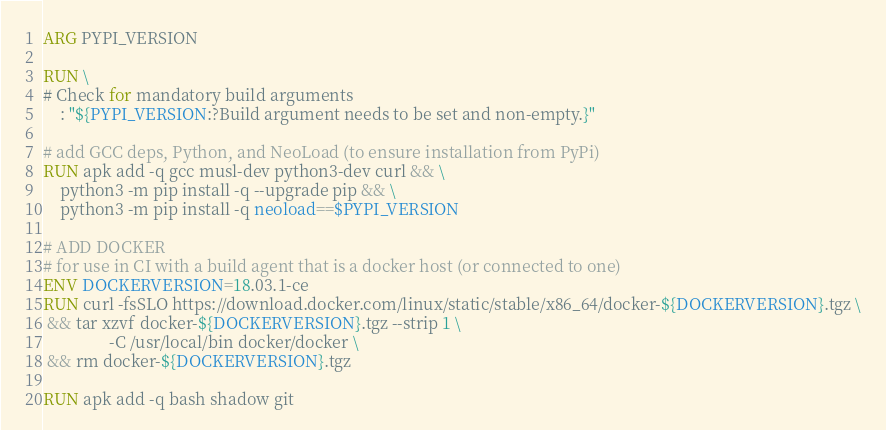Convert code to text. <code><loc_0><loc_0><loc_500><loc_500><_Dockerfile_>
ARG PYPI_VERSION

RUN \
# Check for mandatory build arguments
    : "${PYPI_VERSION:?Build argument needs to be set and non-empty.}"

# add GCC deps, Python, and NeoLoad (to ensure installation from PyPi)
RUN apk add -q gcc musl-dev python3-dev curl && \
    python3 -m pip install -q --upgrade pip && \
    python3 -m pip install -q neoload==$PYPI_VERSION

# ADD DOCKER
# for use in CI with a build agent that is a docker host (or connected to one)
ENV DOCKERVERSION=18.03.1-ce
RUN curl -fsSLO https://download.docker.com/linux/static/stable/x86_64/docker-${DOCKERVERSION}.tgz \
 && tar xzvf docker-${DOCKERVERSION}.tgz --strip 1 \
                -C /usr/local/bin docker/docker \
 && rm docker-${DOCKERVERSION}.tgz

RUN apk add -q bash shadow git
</code> 